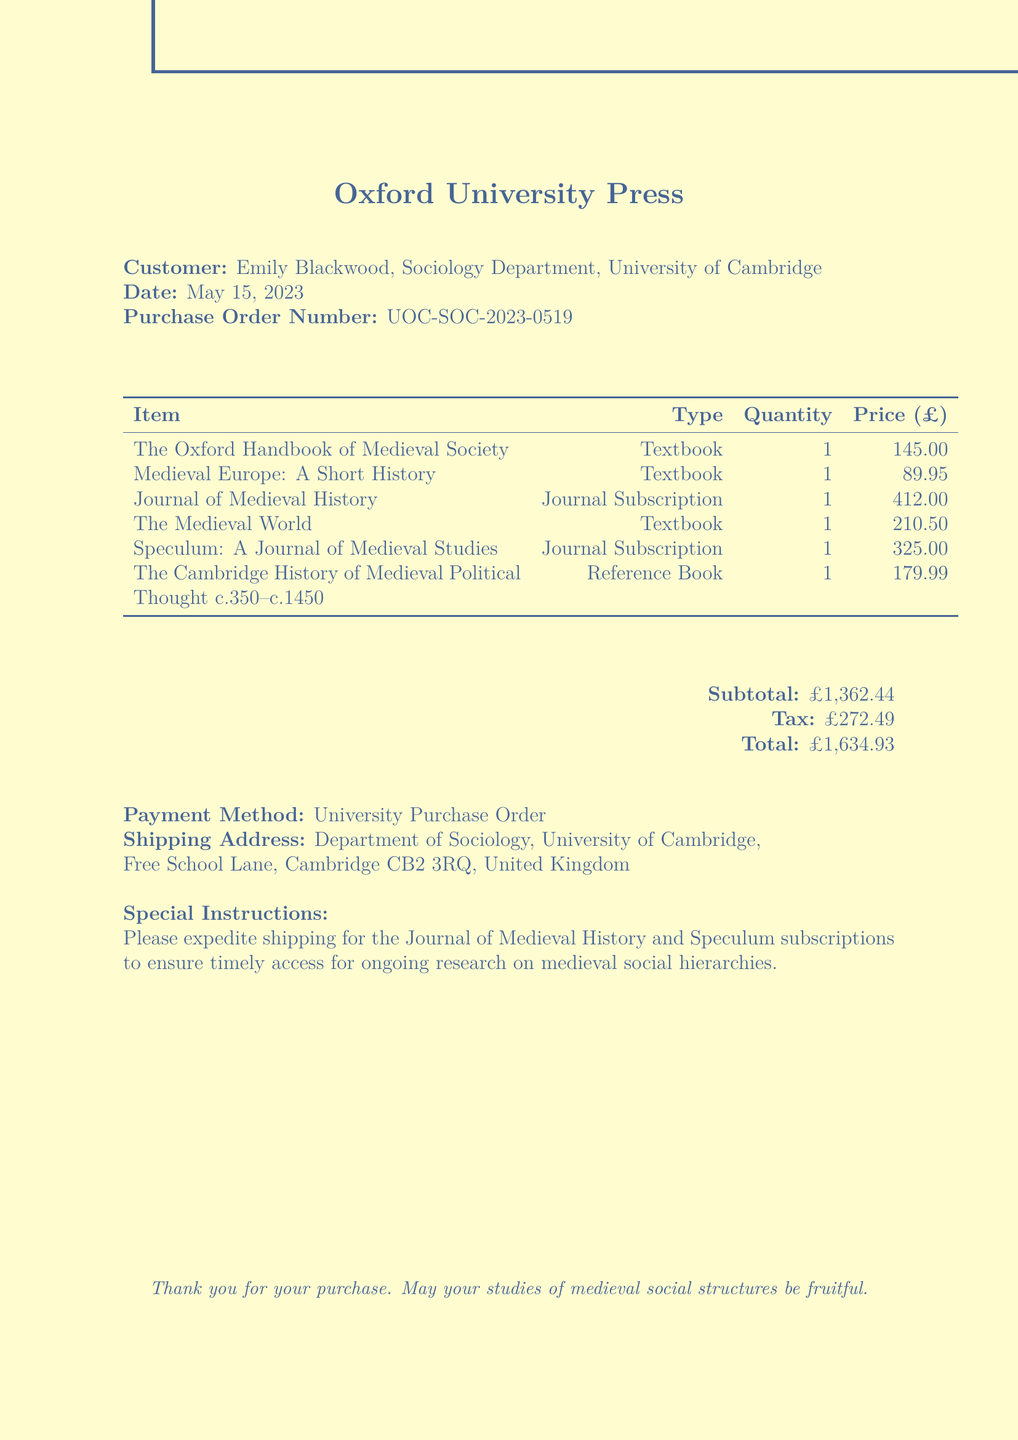What is the total amount of the transaction? The total amount is listed at the end of the document as the sum of the subtotal and tax.
Answer: £1,634.93 Who is the customer? The name and affiliation of the customer are indicated at the top of the document.
Answer: Emily Blackwood, Sociology Department, University of Cambridge What is the publication date of the transaction? The transaction date is specified under the customer information.
Answer: May 15, 2023 What is the primary payment method used? The payment method is clearly stated in the document.
Answer: University Purchase Order How many textbooks were purchased in total? The number of textbooks can be understood by counting the entries labeled as "Textbook."
Answer: 3 What is the price of "Medieval Europe: A Short History"? This specific textbook's price is listed in the itemized cost.
Answer: £89.95 Which item has the highest price? The prices of the items can be compared to determine which one is the most expensive.
Answer: Journal of Medieval History What special instructions were given? The special instructions are noted at the bottom of the document to indicate specific shipping needs.
Answer: Please expedite shipping for the Journal of Medieval History and Speculum subscriptions What is the shipping address? The complete shipping address is provided in the document under a specific section.
Answer: Department of Sociology, University of Cambridge, Free School Lane, Cambridge CB2 3RQ, United Kingdom 